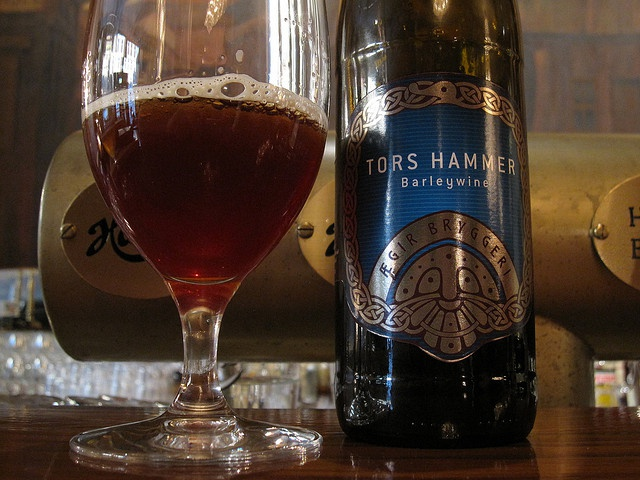Describe the objects in this image and their specific colors. I can see bottle in maroon, black, navy, and gray tones, wine glass in maroon, black, and gray tones, and dining table in maroon, black, and gray tones in this image. 